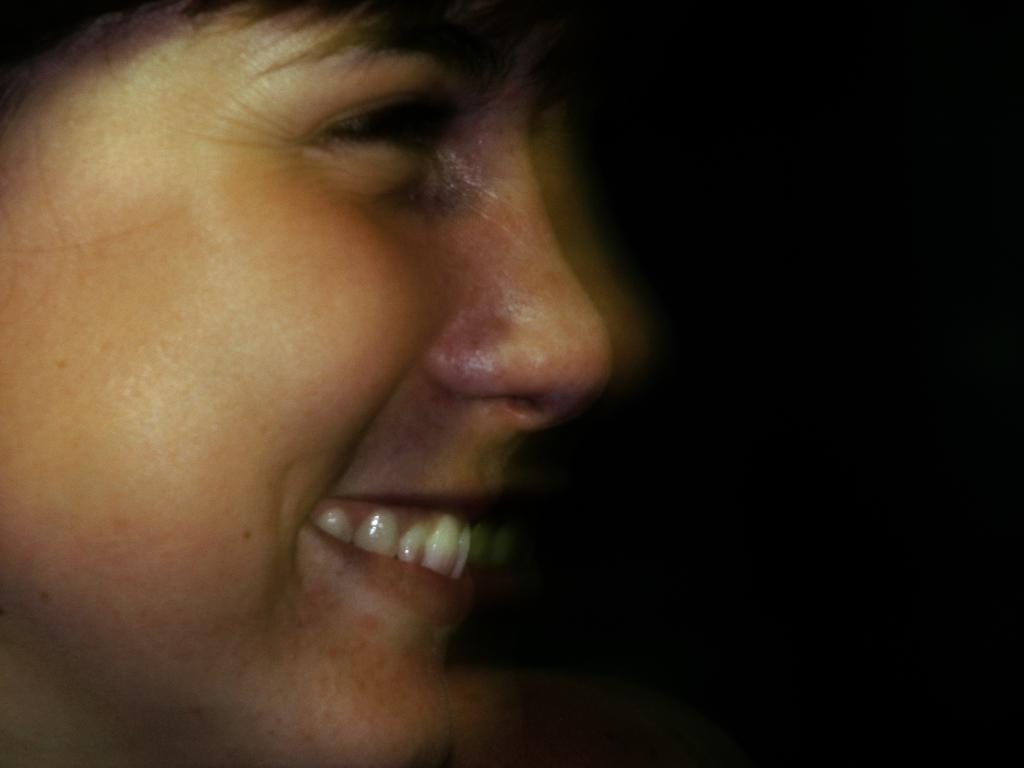Describe this image in one or two sentences. In this image, we can see the face of a person. We can also see the dark background. 